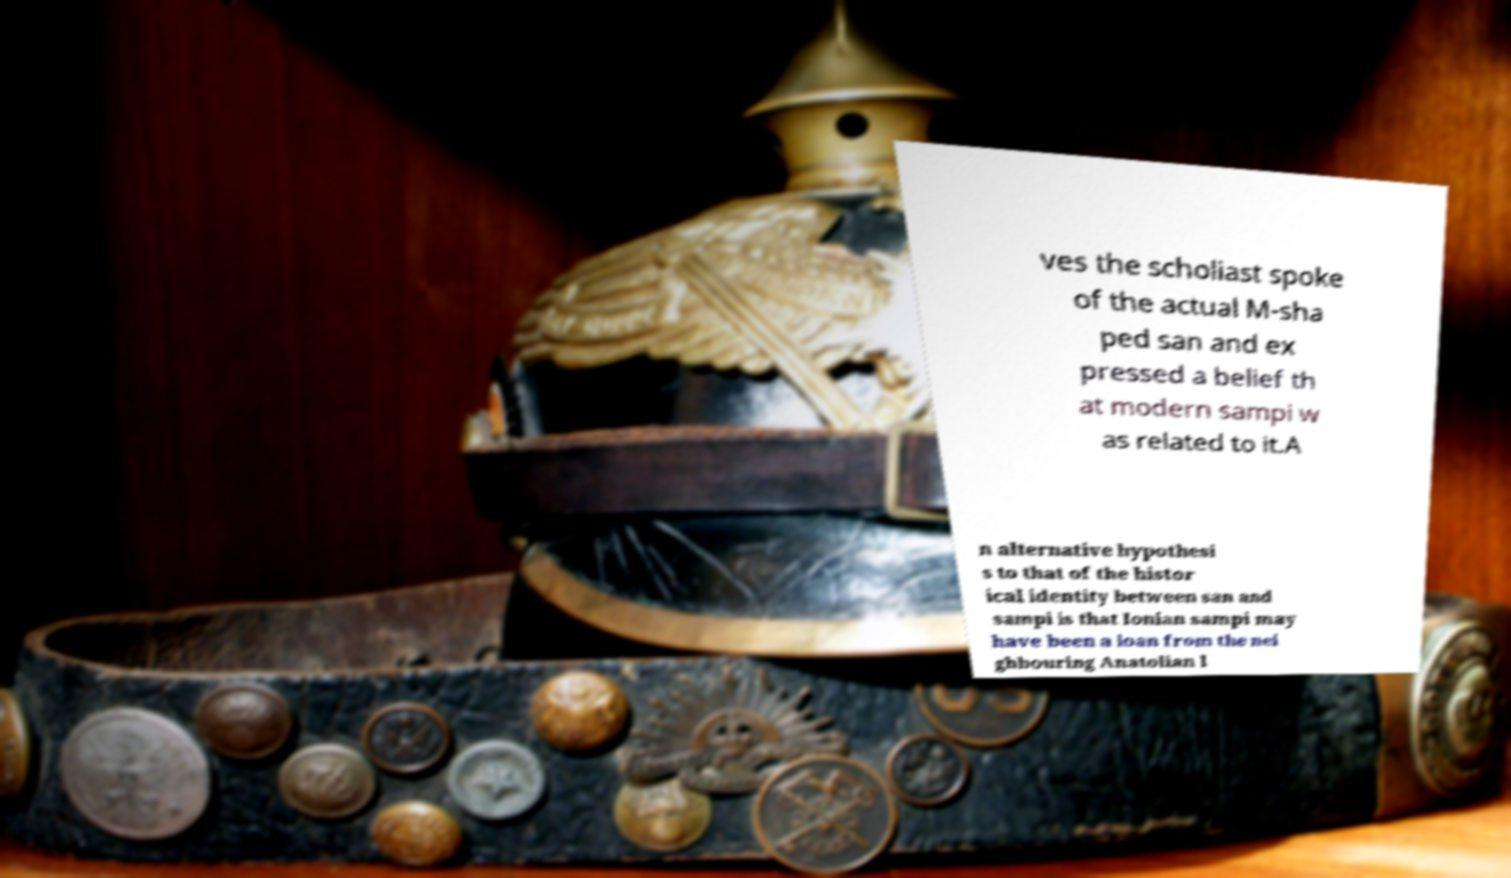There's text embedded in this image that I need extracted. Can you transcribe it verbatim? ves the scholiast spoke of the actual M-sha ped san and ex pressed a belief th at modern sampi w as related to it.A n alternative hypothesi s to that of the histor ical identity between san and sampi is that Ionian sampi may have been a loan from the nei ghbouring Anatolian l 